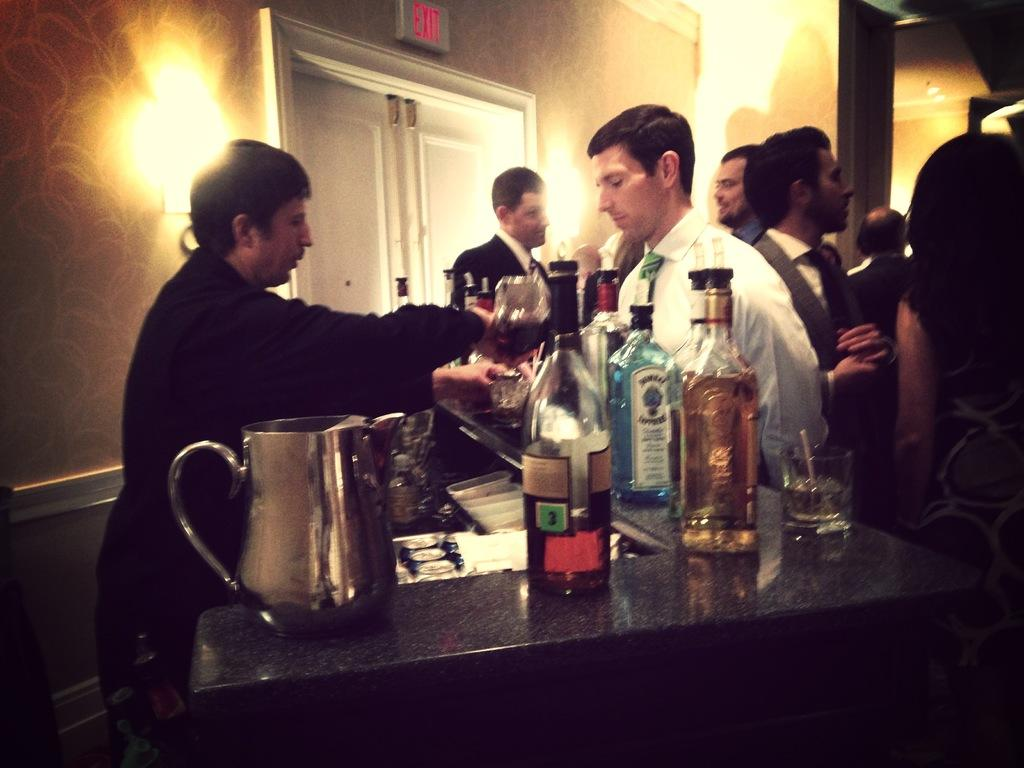Provide a one-sentence caption for the provided image. Bartender pouring drinks with a bottle with writing of Bombay Sapphire Gin. 